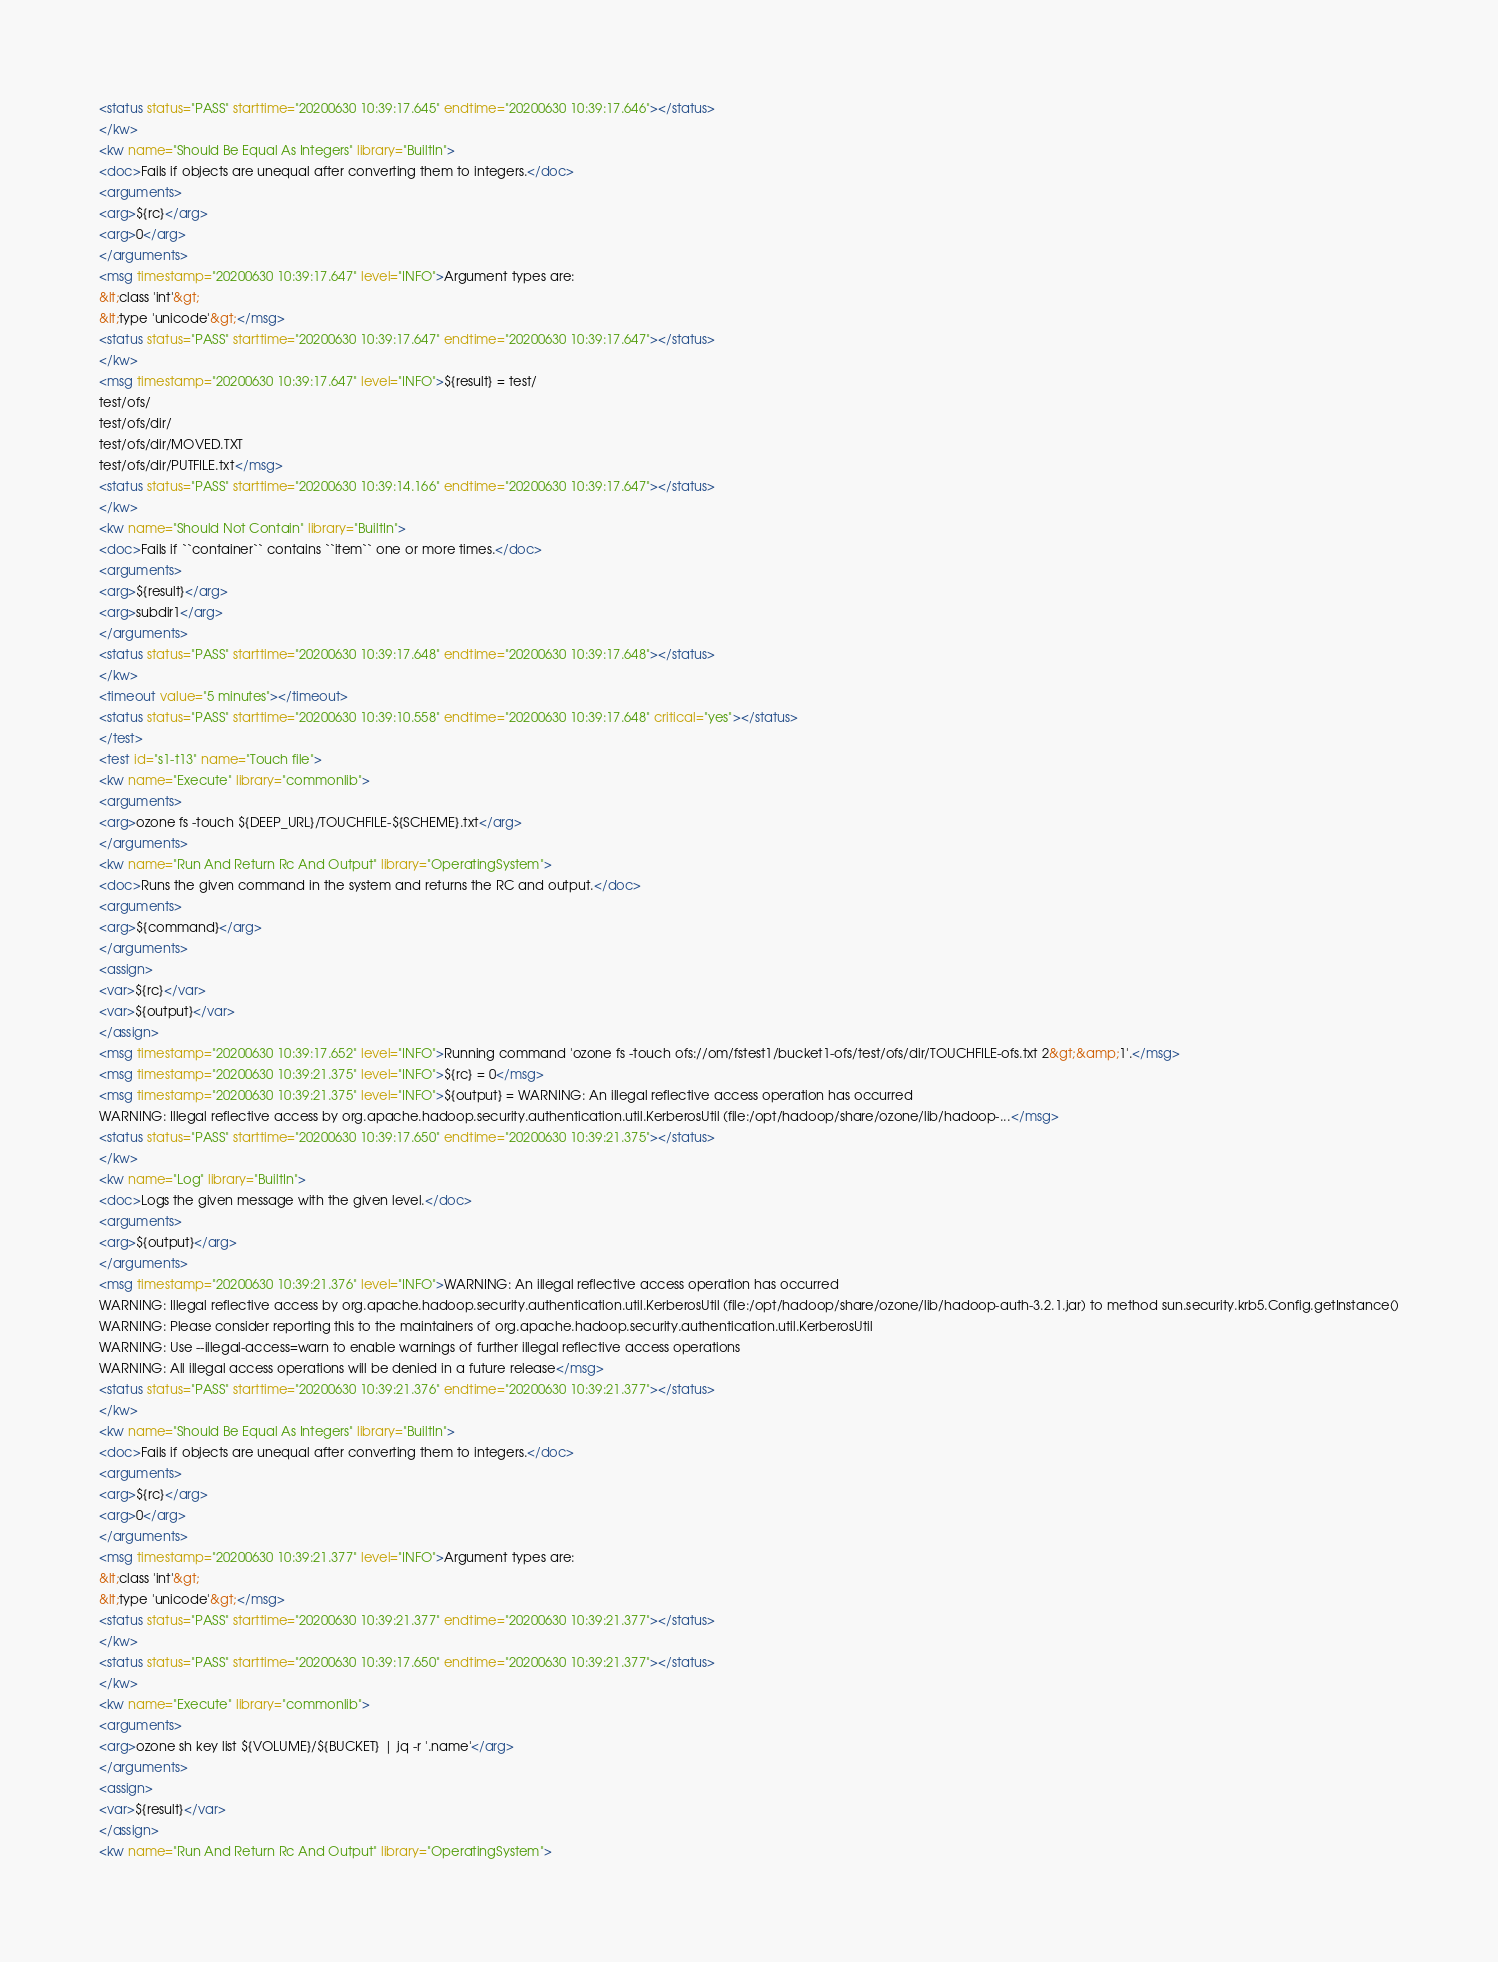Convert code to text. <code><loc_0><loc_0><loc_500><loc_500><_XML_><status status="PASS" starttime="20200630 10:39:17.645" endtime="20200630 10:39:17.646"></status>
</kw>
<kw name="Should Be Equal As Integers" library="BuiltIn">
<doc>Fails if objects are unequal after converting them to integers.</doc>
<arguments>
<arg>${rc}</arg>
<arg>0</arg>
</arguments>
<msg timestamp="20200630 10:39:17.647" level="INFO">Argument types are:
&lt;class 'int'&gt;
&lt;type 'unicode'&gt;</msg>
<status status="PASS" starttime="20200630 10:39:17.647" endtime="20200630 10:39:17.647"></status>
</kw>
<msg timestamp="20200630 10:39:17.647" level="INFO">${result} = test/
test/ofs/
test/ofs/dir/
test/ofs/dir/MOVED.TXT
test/ofs/dir/PUTFILE.txt</msg>
<status status="PASS" starttime="20200630 10:39:14.166" endtime="20200630 10:39:17.647"></status>
</kw>
<kw name="Should Not Contain" library="BuiltIn">
<doc>Fails if ``container`` contains ``item`` one or more times.</doc>
<arguments>
<arg>${result}</arg>
<arg>subdir1</arg>
</arguments>
<status status="PASS" starttime="20200630 10:39:17.648" endtime="20200630 10:39:17.648"></status>
</kw>
<timeout value="5 minutes"></timeout>
<status status="PASS" starttime="20200630 10:39:10.558" endtime="20200630 10:39:17.648" critical="yes"></status>
</test>
<test id="s1-t13" name="Touch file">
<kw name="Execute" library="commonlib">
<arguments>
<arg>ozone fs -touch ${DEEP_URL}/TOUCHFILE-${SCHEME}.txt</arg>
</arguments>
<kw name="Run And Return Rc And Output" library="OperatingSystem">
<doc>Runs the given command in the system and returns the RC and output.</doc>
<arguments>
<arg>${command}</arg>
</arguments>
<assign>
<var>${rc}</var>
<var>${output}</var>
</assign>
<msg timestamp="20200630 10:39:17.652" level="INFO">Running command 'ozone fs -touch ofs://om/fstest1/bucket1-ofs/test/ofs/dir/TOUCHFILE-ofs.txt 2&gt;&amp;1'.</msg>
<msg timestamp="20200630 10:39:21.375" level="INFO">${rc} = 0</msg>
<msg timestamp="20200630 10:39:21.375" level="INFO">${output} = WARNING: An illegal reflective access operation has occurred
WARNING: Illegal reflective access by org.apache.hadoop.security.authentication.util.KerberosUtil (file:/opt/hadoop/share/ozone/lib/hadoop-...</msg>
<status status="PASS" starttime="20200630 10:39:17.650" endtime="20200630 10:39:21.375"></status>
</kw>
<kw name="Log" library="BuiltIn">
<doc>Logs the given message with the given level.</doc>
<arguments>
<arg>${output}</arg>
</arguments>
<msg timestamp="20200630 10:39:21.376" level="INFO">WARNING: An illegal reflective access operation has occurred
WARNING: Illegal reflective access by org.apache.hadoop.security.authentication.util.KerberosUtil (file:/opt/hadoop/share/ozone/lib/hadoop-auth-3.2.1.jar) to method sun.security.krb5.Config.getInstance()
WARNING: Please consider reporting this to the maintainers of org.apache.hadoop.security.authentication.util.KerberosUtil
WARNING: Use --illegal-access=warn to enable warnings of further illegal reflective access operations
WARNING: All illegal access operations will be denied in a future release</msg>
<status status="PASS" starttime="20200630 10:39:21.376" endtime="20200630 10:39:21.377"></status>
</kw>
<kw name="Should Be Equal As Integers" library="BuiltIn">
<doc>Fails if objects are unequal after converting them to integers.</doc>
<arguments>
<arg>${rc}</arg>
<arg>0</arg>
</arguments>
<msg timestamp="20200630 10:39:21.377" level="INFO">Argument types are:
&lt;class 'int'&gt;
&lt;type 'unicode'&gt;</msg>
<status status="PASS" starttime="20200630 10:39:21.377" endtime="20200630 10:39:21.377"></status>
</kw>
<status status="PASS" starttime="20200630 10:39:17.650" endtime="20200630 10:39:21.377"></status>
</kw>
<kw name="Execute" library="commonlib">
<arguments>
<arg>ozone sh key list ${VOLUME}/${BUCKET} | jq -r '.name'</arg>
</arguments>
<assign>
<var>${result}</var>
</assign>
<kw name="Run And Return Rc And Output" library="OperatingSystem"></code> 